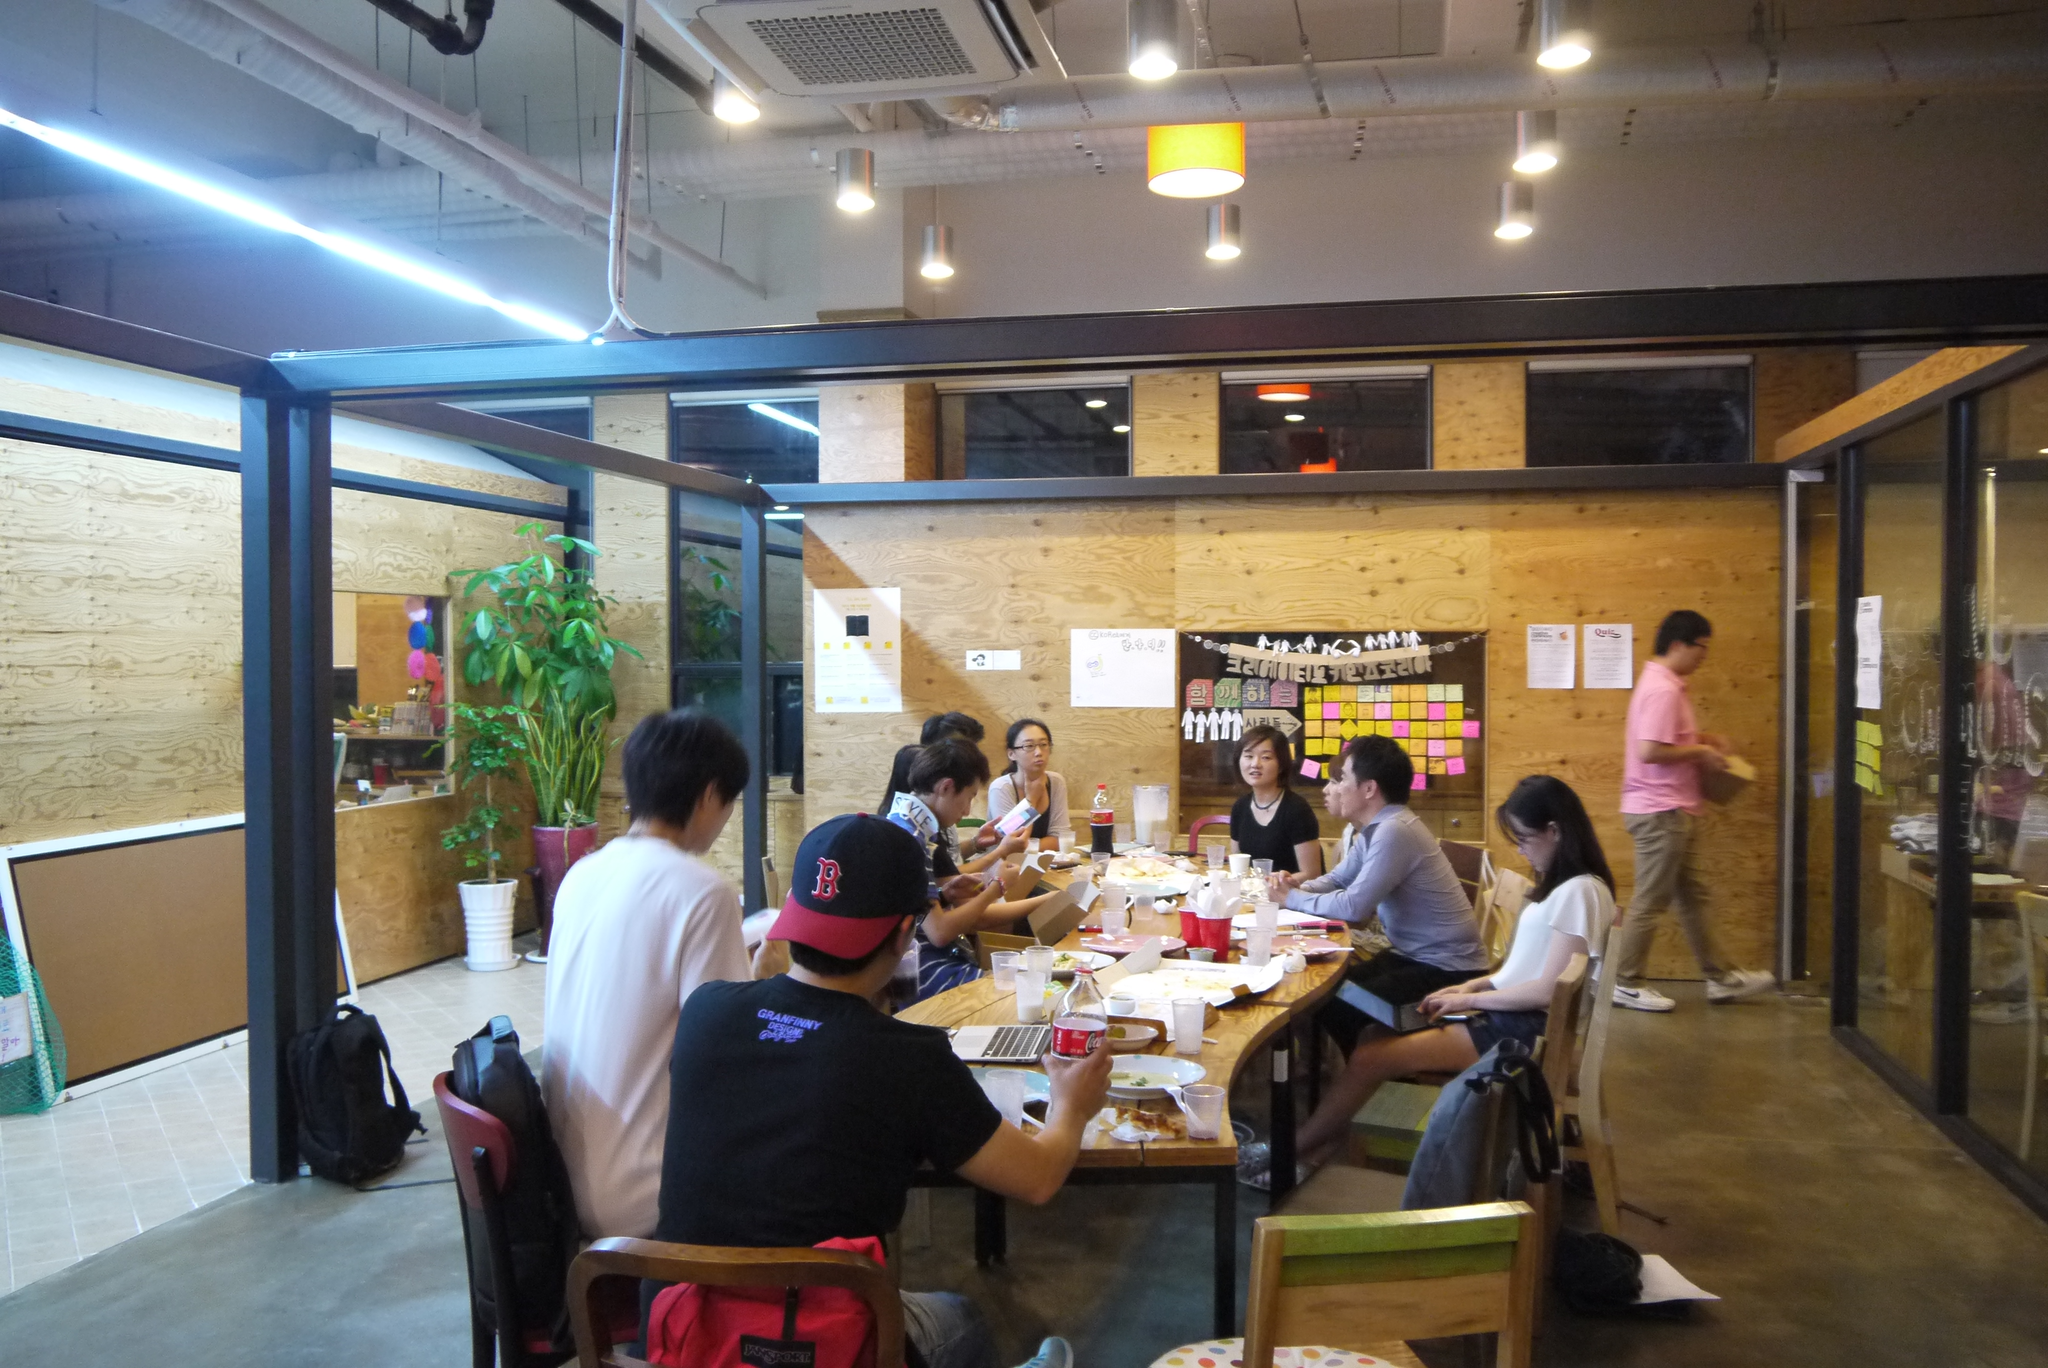In one or two sentences, can you explain what this image depicts? I think this picture is taken in a restaurant. There are group of people sitting around a table. In the center there is a man wearing a black t shirt and black hat, besides there is another man, he is wearing a white t shirt. Behind him there is a bag on the chair. Towards the left there is a pillar, before it there is a black bag. Towards the right there is a man wearing a pink t shirt, cream trousers, he is walking towards the door. There are two plants in the image. In the top there are lights. 